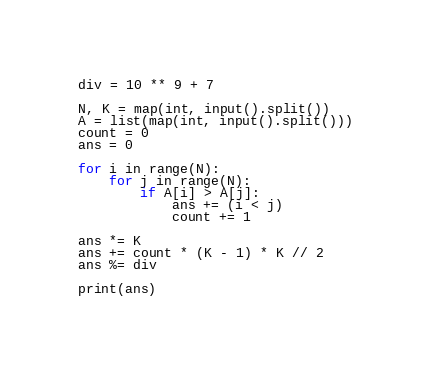Convert code to text. <code><loc_0><loc_0><loc_500><loc_500><_Python_>div = 10 ** 9 + 7

N, K = map(int, input().split())
A = list(map(int, input().split()))
count = 0
ans = 0

for i in range(N):
    for j in range(N):
        if A[i] > A[j]:
            ans += (i < j)
            count += 1

ans *= K
ans += count * (K - 1) * K // 2
ans %= div

print(ans)</code> 